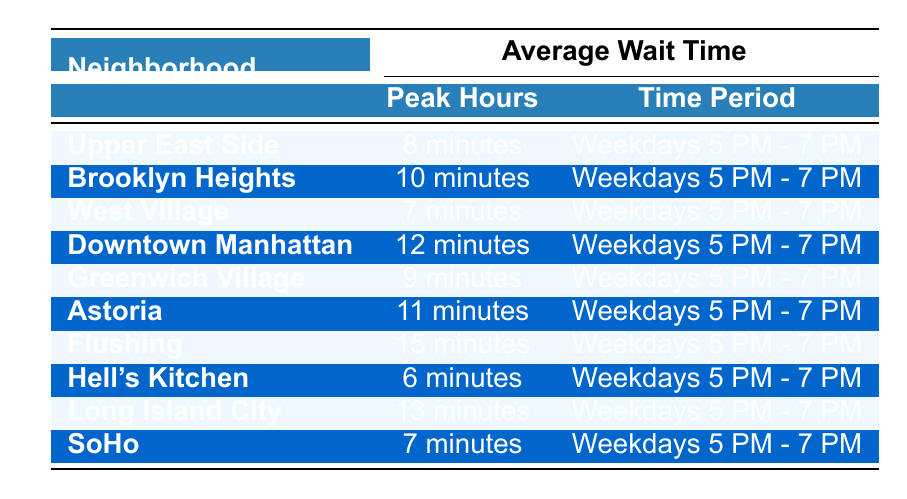What is the average wait time for Uber pickups in Hell's Kitchen? The table shows that the average wait time for Uber in Hell's Kitchen during peak hours is 6 minutes.
Answer: 6 minutes Which neighborhood has the longest average wait time for Uber pickups? Flushing has the longest average wait time listed at 15 minutes, according to the table.
Answer: Flushing How much longer is the average wait time in Downtown Manhattan compared to West Village? The average wait time in Downtown Manhattan is 12 minutes, and in West Village, it is 7 minutes. Therefore, the difference is 12 - 7 = 5 minutes.
Answer: 5 minutes Is the average wait time in Soho less than 10 minutes? The table indicates that Soho has an average wait time of 7 minutes, which is indeed less than 10 minutes.
Answer: Yes What is the average wait time across all neighborhoods during peak hours? The average wait times are 8, 10, 7, 12, 9, 11, 15, 6, 13, and 7 minutes. Adding these gives a total of 88 minutes and dividing by 10 neighborhoods yields an average of 8.8 minutes.
Answer: 8.8 minutes Which neighborhood has a shorter wait time than Astoria? According to the table, Hell's Kitchen (6 minutes), West Village (7 minutes), and Soho (7 minutes) have shorter wait times than Astoria, which is 11 minutes.
Answer: Hell's Kitchen, West Village, Soho What is the difference in average wait times between Upper East Side and Flushing? The Upper East Side has an average wait time of 8 minutes, while Flushing has 15 minutes. The difference is 15 - 8 = 7 minutes.
Answer: 7 minutes Which neighborhoods have the same average wait time of 7 minutes? West Village and Soho both have the same average wait time of 7 minutes as shown in the table.
Answer: West Village, Soho If you add the average wait times of Brooklyn Heights and Greenwich Village, what is the total? Brooklyn Heights has an average wait time of 10 minutes and Greenwich Village has 9 minutes. Adding these gives 10 + 9 = 19 minutes.
Answer: 19 minutes Which neighborhood has the shortest average wait time, and how many minutes shorter is it than the longest wait time? The shortest wait time is in Hell's Kitchen at 6 minutes, while the longest is in Flushing at 15 minutes. The difference is 15 - 6 = 9 minutes.
Answer: 9 minutes 